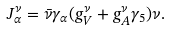<formula> <loc_0><loc_0><loc_500><loc_500>J _ { \alpha } ^ { \nu } = \bar { \nu } \gamma _ { \alpha } ( g _ { V } ^ { \nu } + g _ { A } ^ { \nu } \gamma _ { 5 } ) \nu .</formula> 